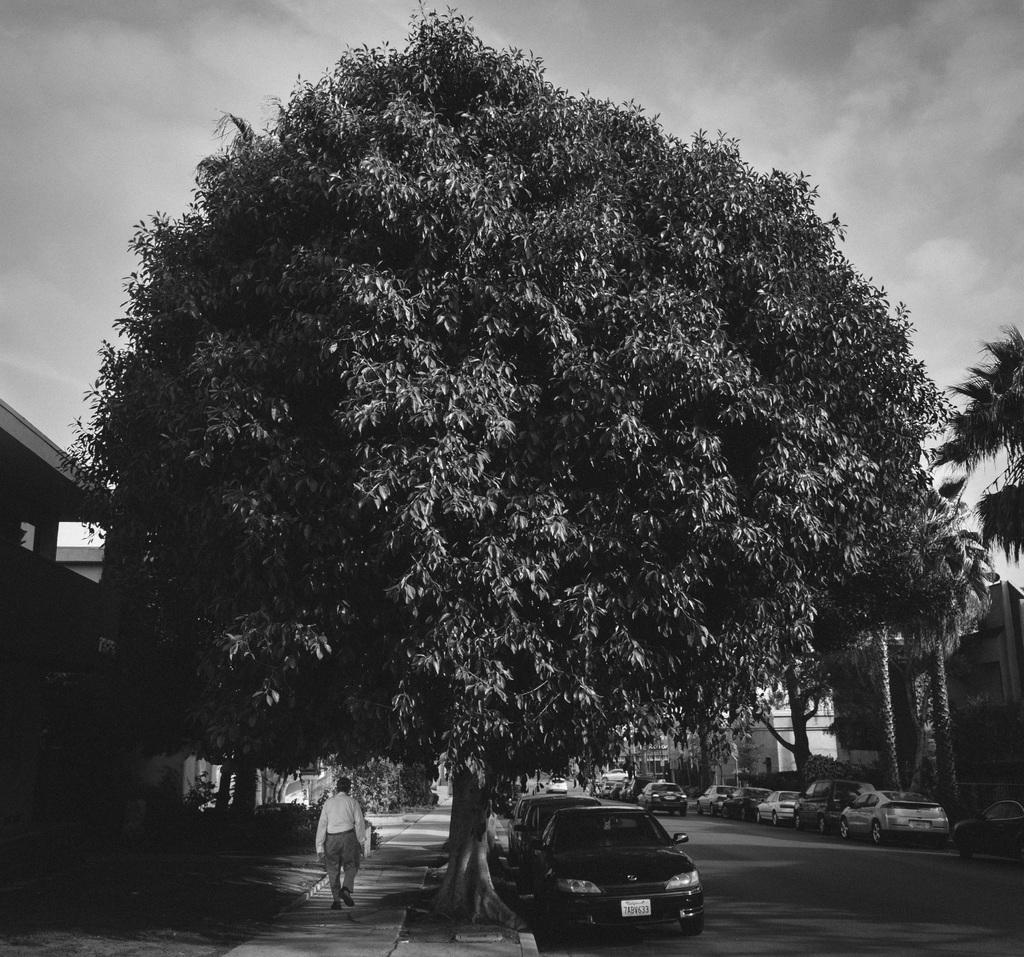Could you give a brief overview of what you see in this image? In the center of the image there are cars parked on the road. There is a person walking on the pavement. On both right and left side of the image there are buildings. There are trees. In the background of the image there is sky. 